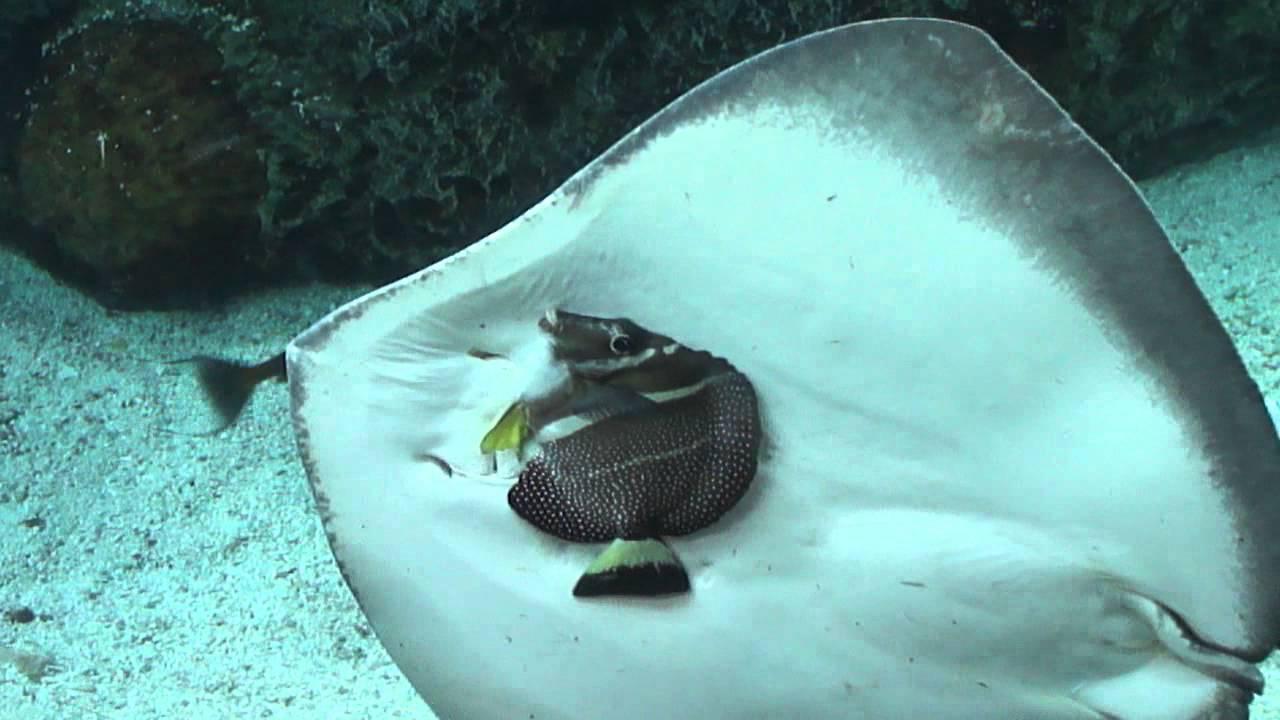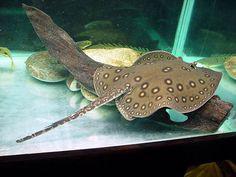The first image is the image on the left, the second image is the image on the right. Assess this claim about the two images: "At least one image contains a sea creature that is not a stingray.". Correct or not? Answer yes or no. Yes. 